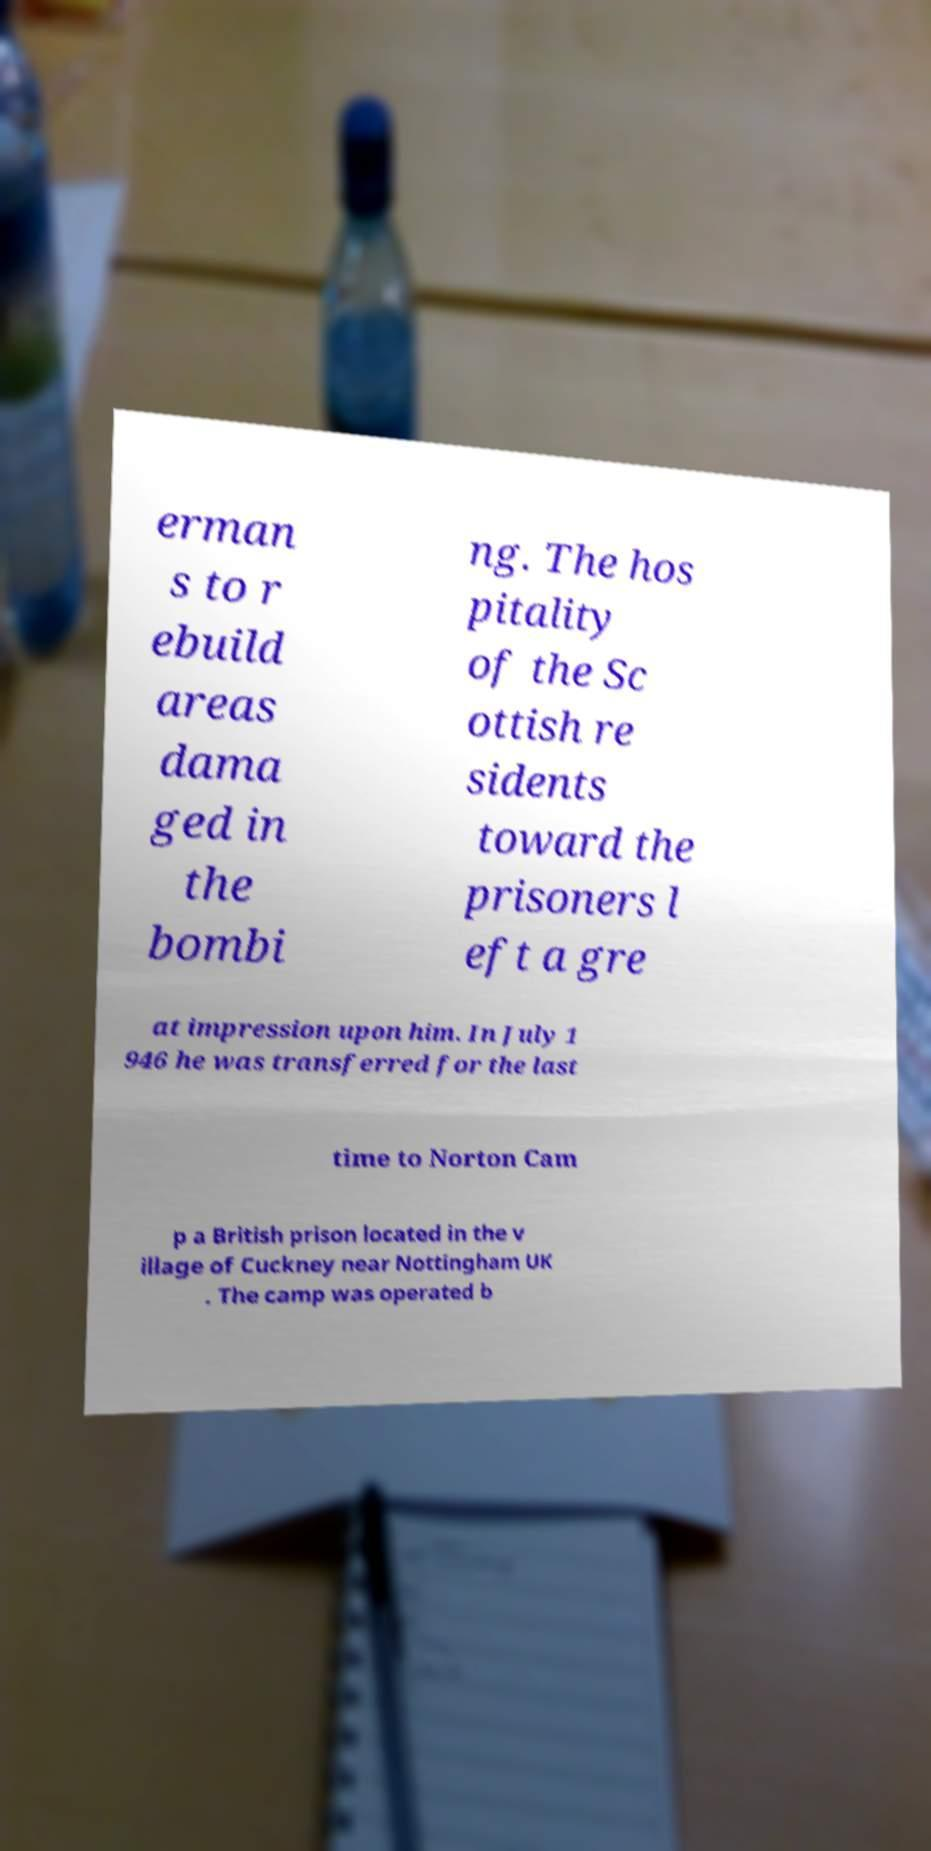Could you assist in decoding the text presented in this image and type it out clearly? erman s to r ebuild areas dama ged in the bombi ng. The hos pitality of the Sc ottish re sidents toward the prisoners l eft a gre at impression upon him. In July 1 946 he was transferred for the last time to Norton Cam p a British prison located in the v illage of Cuckney near Nottingham UK . The camp was operated b 